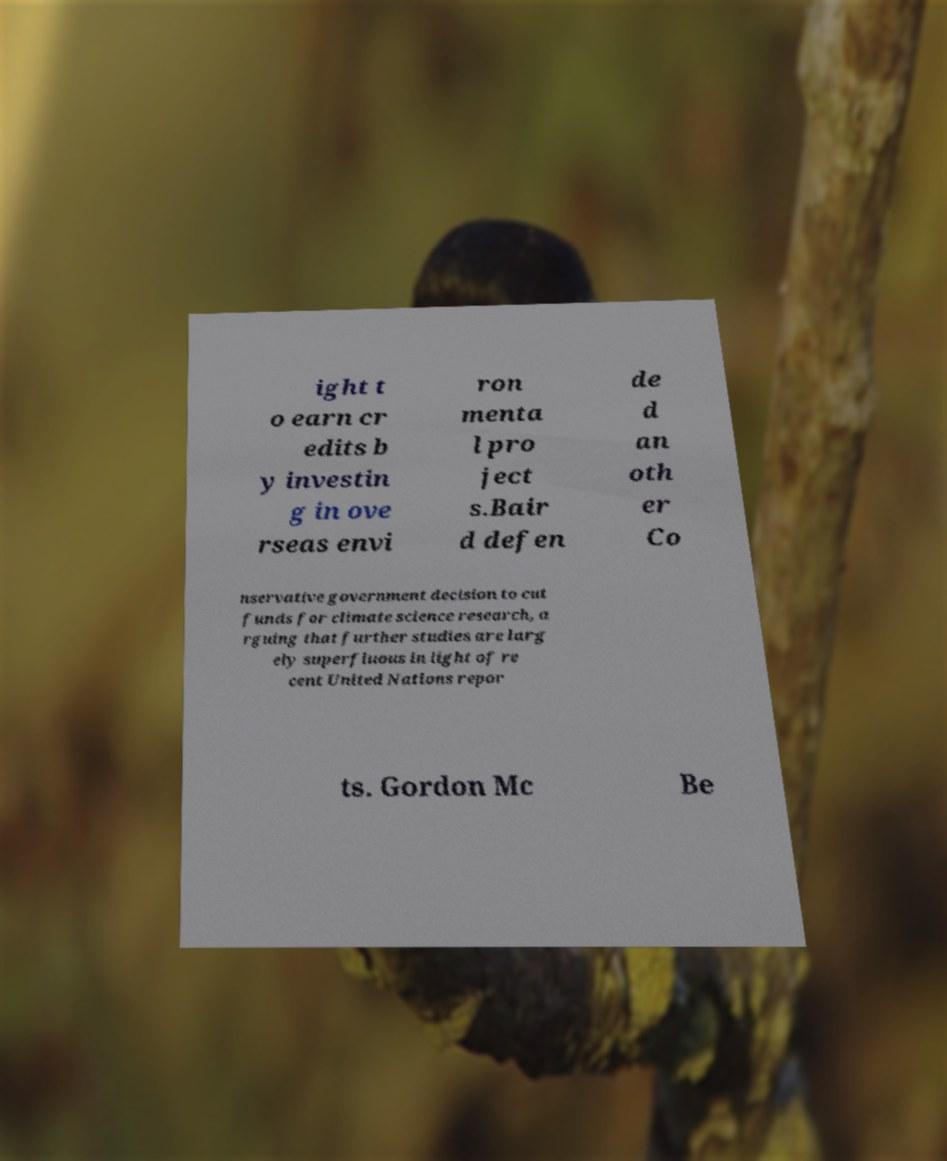Can you accurately transcribe the text from the provided image for me? ight t o earn cr edits b y investin g in ove rseas envi ron menta l pro ject s.Bair d defen de d an oth er Co nservative government decision to cut funds for climate science research, a rguing that further studies are larg ely superfluous in light of re cent United Nations repor ts. Gordon Mc Be 